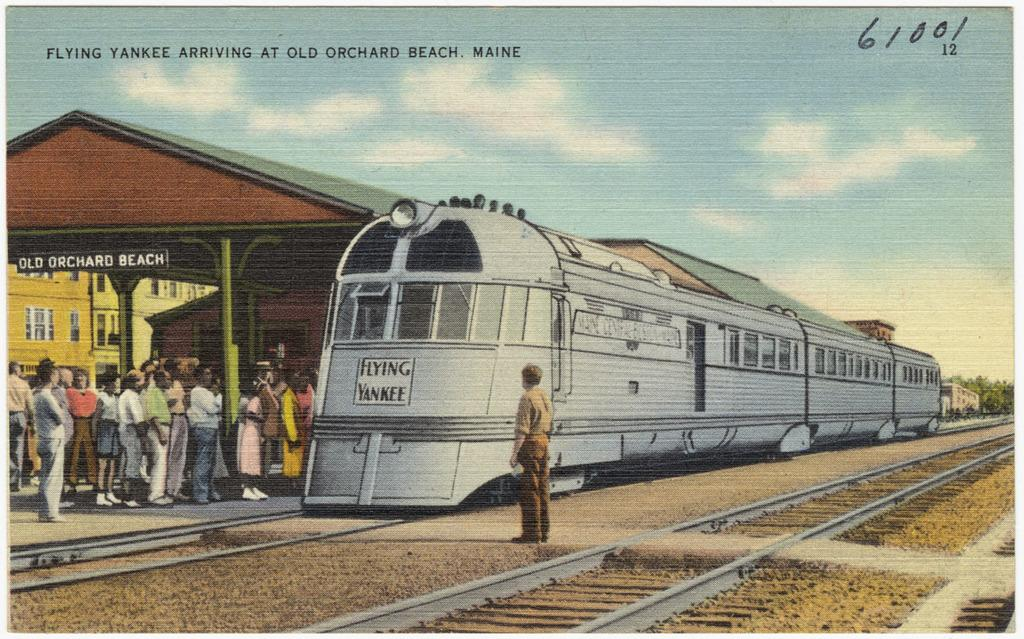Provide a one-sentence caption for the provided image. A postcard depicts a train and the number 61001 in the corner. 